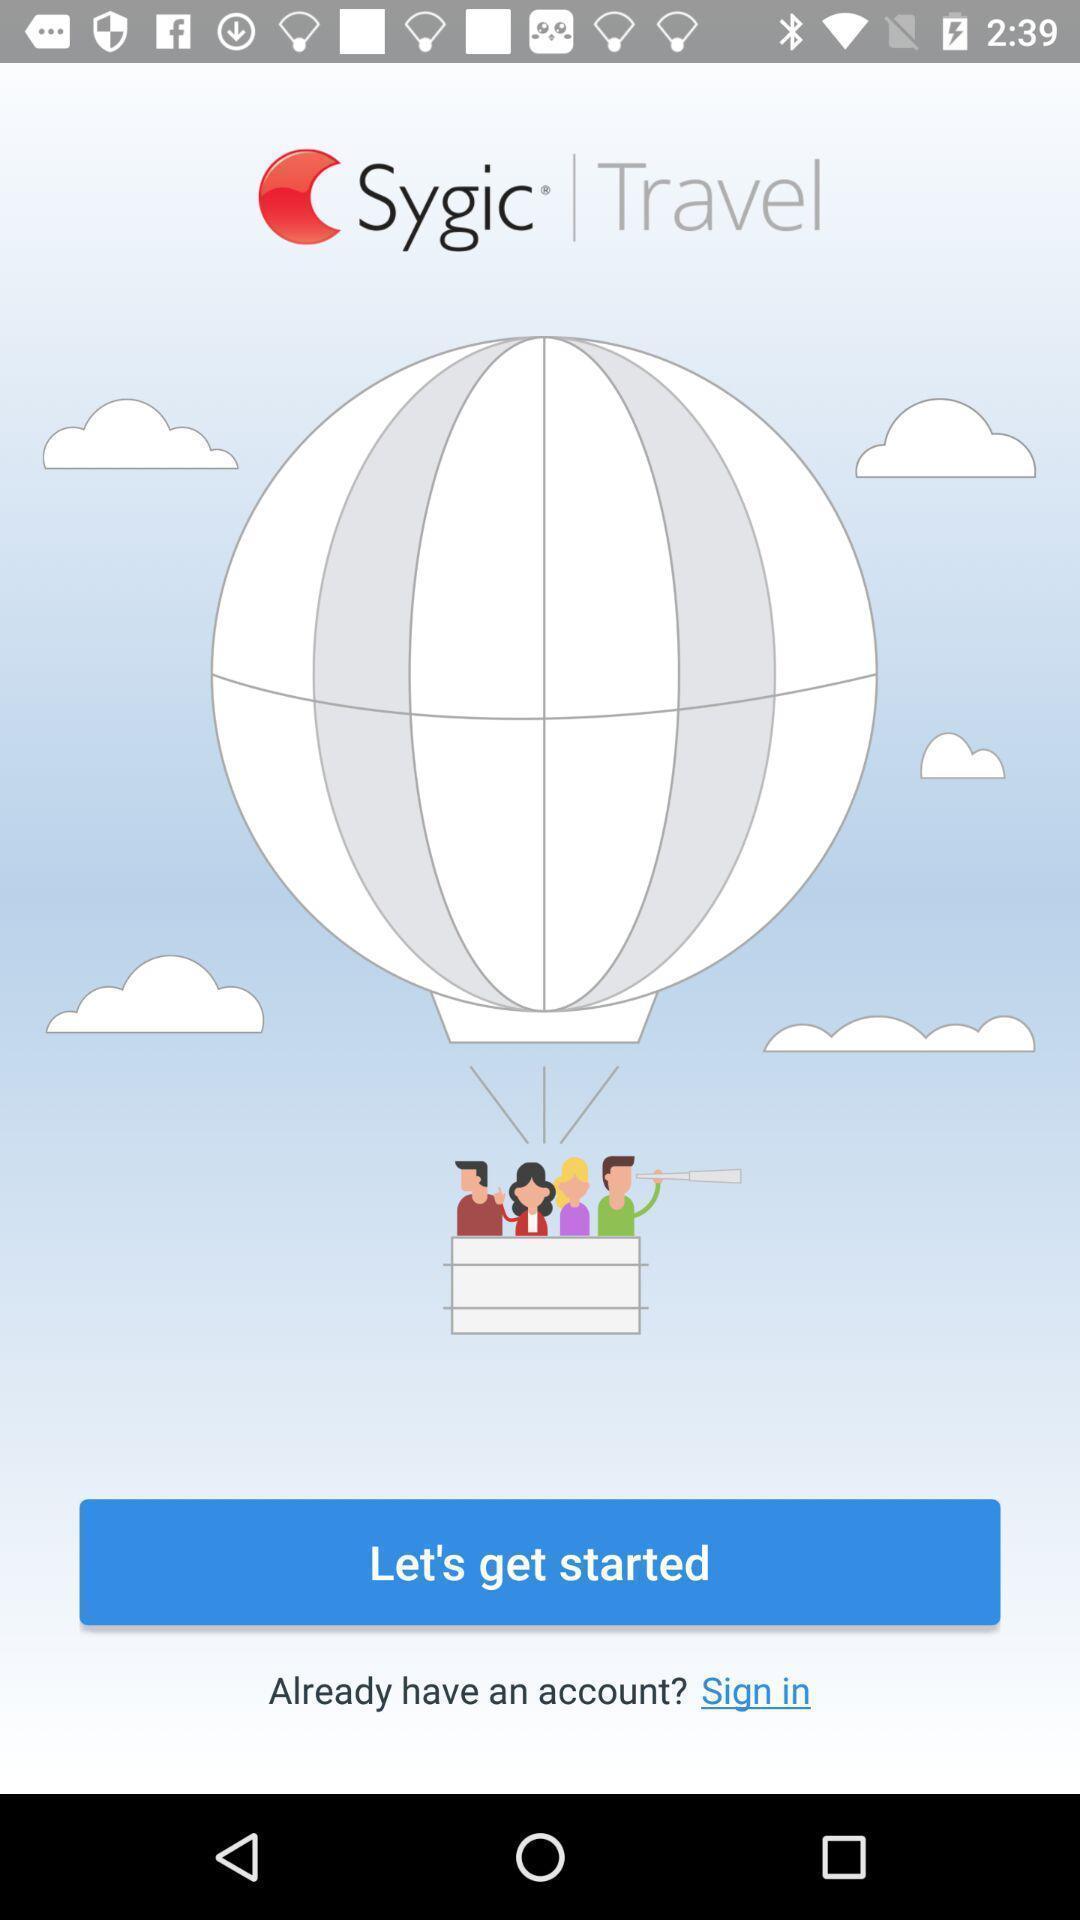Give me a narrative description of this picture. Welcome page of an travel app. 